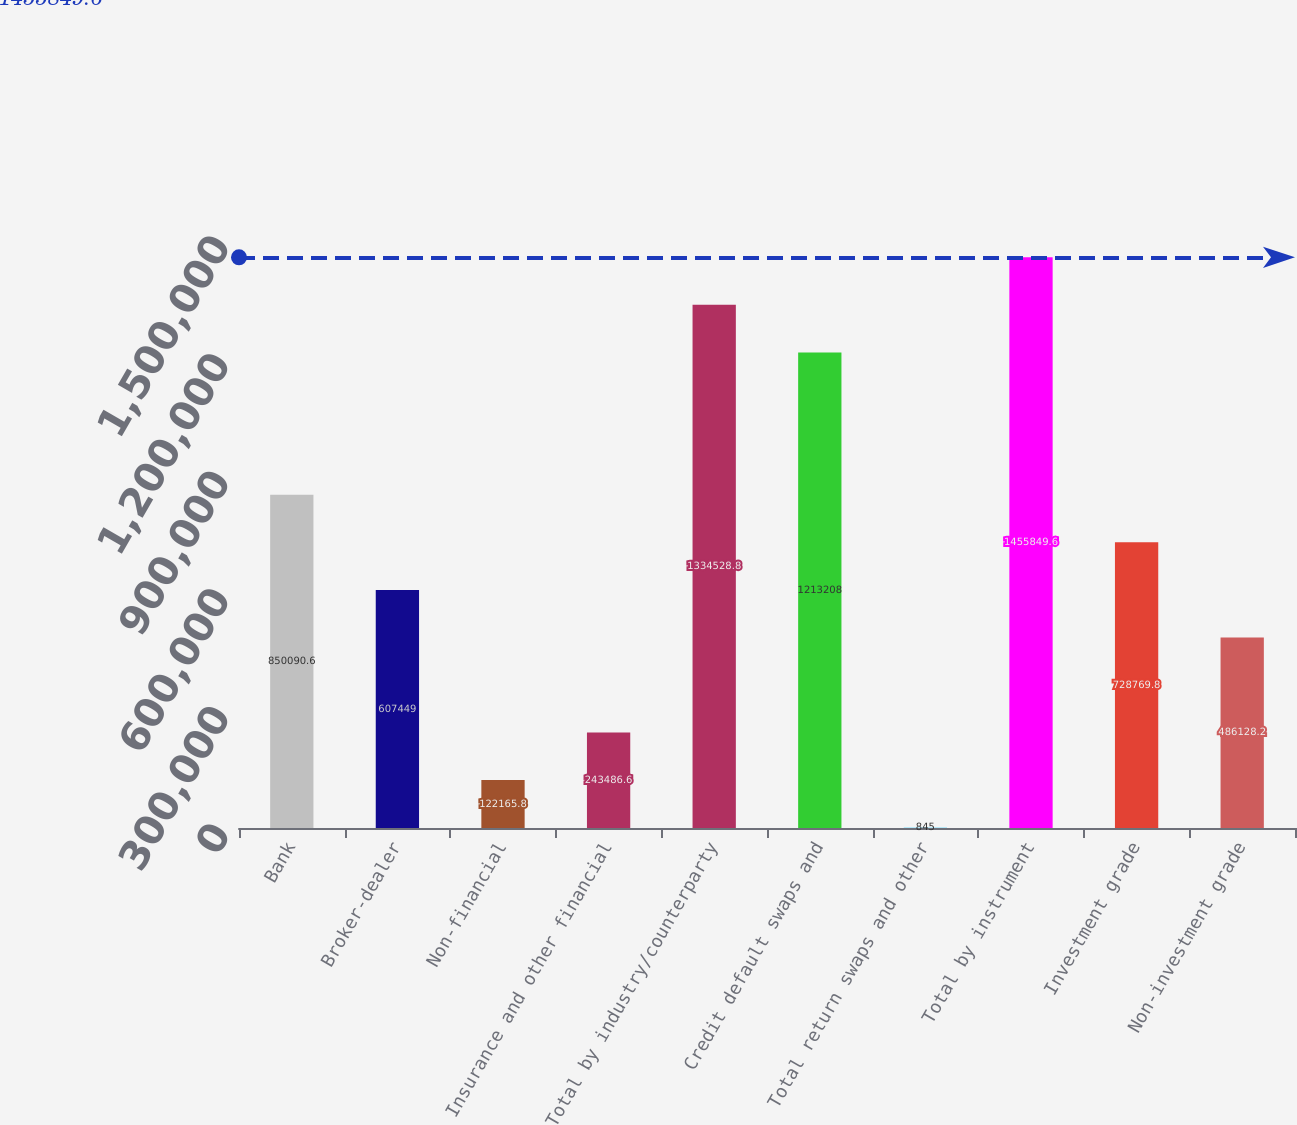Convert chart. <chart><loc_0><loc_0><loc_500><loc_500><bar_chart><fcel>Bank<fcel>Broker-dealer<fcel>Non-financial<fcel>Insurance and other financial<fcel>Total by industry/counterparty<fcel>Credit default swaps and<fcel>Total return swaps and other<fcel>Total by instrument<fcel>Investment grade<fcel>Non-investment grade<nl><fcel>850091<fcel>607449<fcel>122166<fcel>243487<fcel>1.33453e+06<fcel>1.21321e+06<fcel>845<fcel>1.45585e+06<fcel>728770<fcel>486128<nl></chart> 